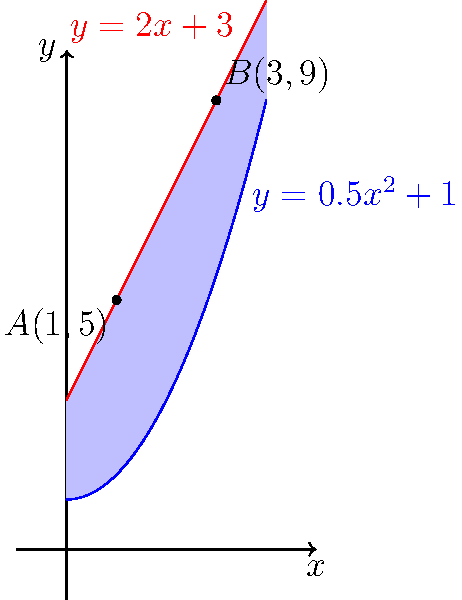In a financial analysis, two performance metrics are represented by the functions $y=0.5x^2+1$ (blue curve) and $y=2x+3$ (red curve). The area between these curves represents a complex financial indicator. Calculate the area of this region bounded by the two curves and the vertical lines at $x=1$ and $x=3$. To find the area between the two curves, we need to:

1) Find the points of intersection:
   Solve $0.5x^2+1 = 2x+3$
   $0.5x^2-2x-2 = 0$
   $(x-2)(0.5x+1) = 0$
   $x = 1$ or $x = -2$ (discard as it's outside our range)

2) Set up the integral:
   Area = $\int_1^3 [(2x+3) - (0.5x^2+1)] dx$

3) Evaluate the integral:
   $\int_1^3 [(2x+3) - (0.5x^2+1)] dx$
   $= \int_1^3 [2x+3-0.5x^2-1] dx$
   $= \int_1^3 [-0.5x^2+2x+2] dx$
   $= [-\frac{1}{6}x^3+x^2+2x]_1^3$

4) Calculate the result:
   $= [-\frac{1}{6}(3^3)+3^2+2(3)] - [-\frac{1}{6}(1^3)+1^2+2(1)]$
   $= [-\frac{9}{2}+9+6] - [-\frac{1}{6}+1+2]$
   $= [14.5] - [2.833]$
   $= 11.667$

Therefore, the area is approximately 11.667 square units.
Answer: 11.667 square units 